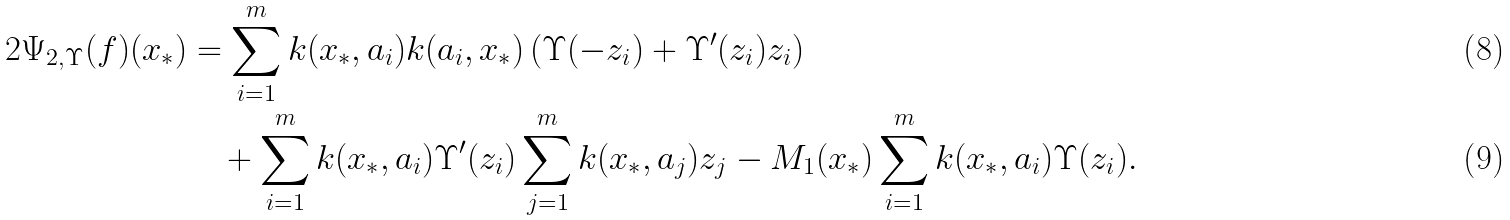<formula> <loc_0><loc_0><loc_500><loc_500>2 \Psi _ { 2 , \Upsilon } ( f ) ( x _ { * } ) & = \sum _ { i = 1 } ^ { m } k ( x _ { * } , a _ { i } ) k ( a _ { i } , x _ { * } ) \left ( \Upsilon ( - z _ { i } ) + \Upsilon ^ { \prime } ( z _ { i } ) z _ { i } \right ) \\ & \quad + \sum _ { i = 1 } ^ { m } k ( x _ { * } , a _ { i } ) \Upsilon ^ { \prime } ( z _ { i } ) \sum _ { j = 1 } ^ { m } k ( x _ { * } , a _ { j } ) z _ { j } - M _ { 1 } ( x _ { * } ) \sum _ { i = 1 } ^ { m } k ( x _ { * } , a _ { i } ) \Upsilon ( z _ { i } ) .</formula> 